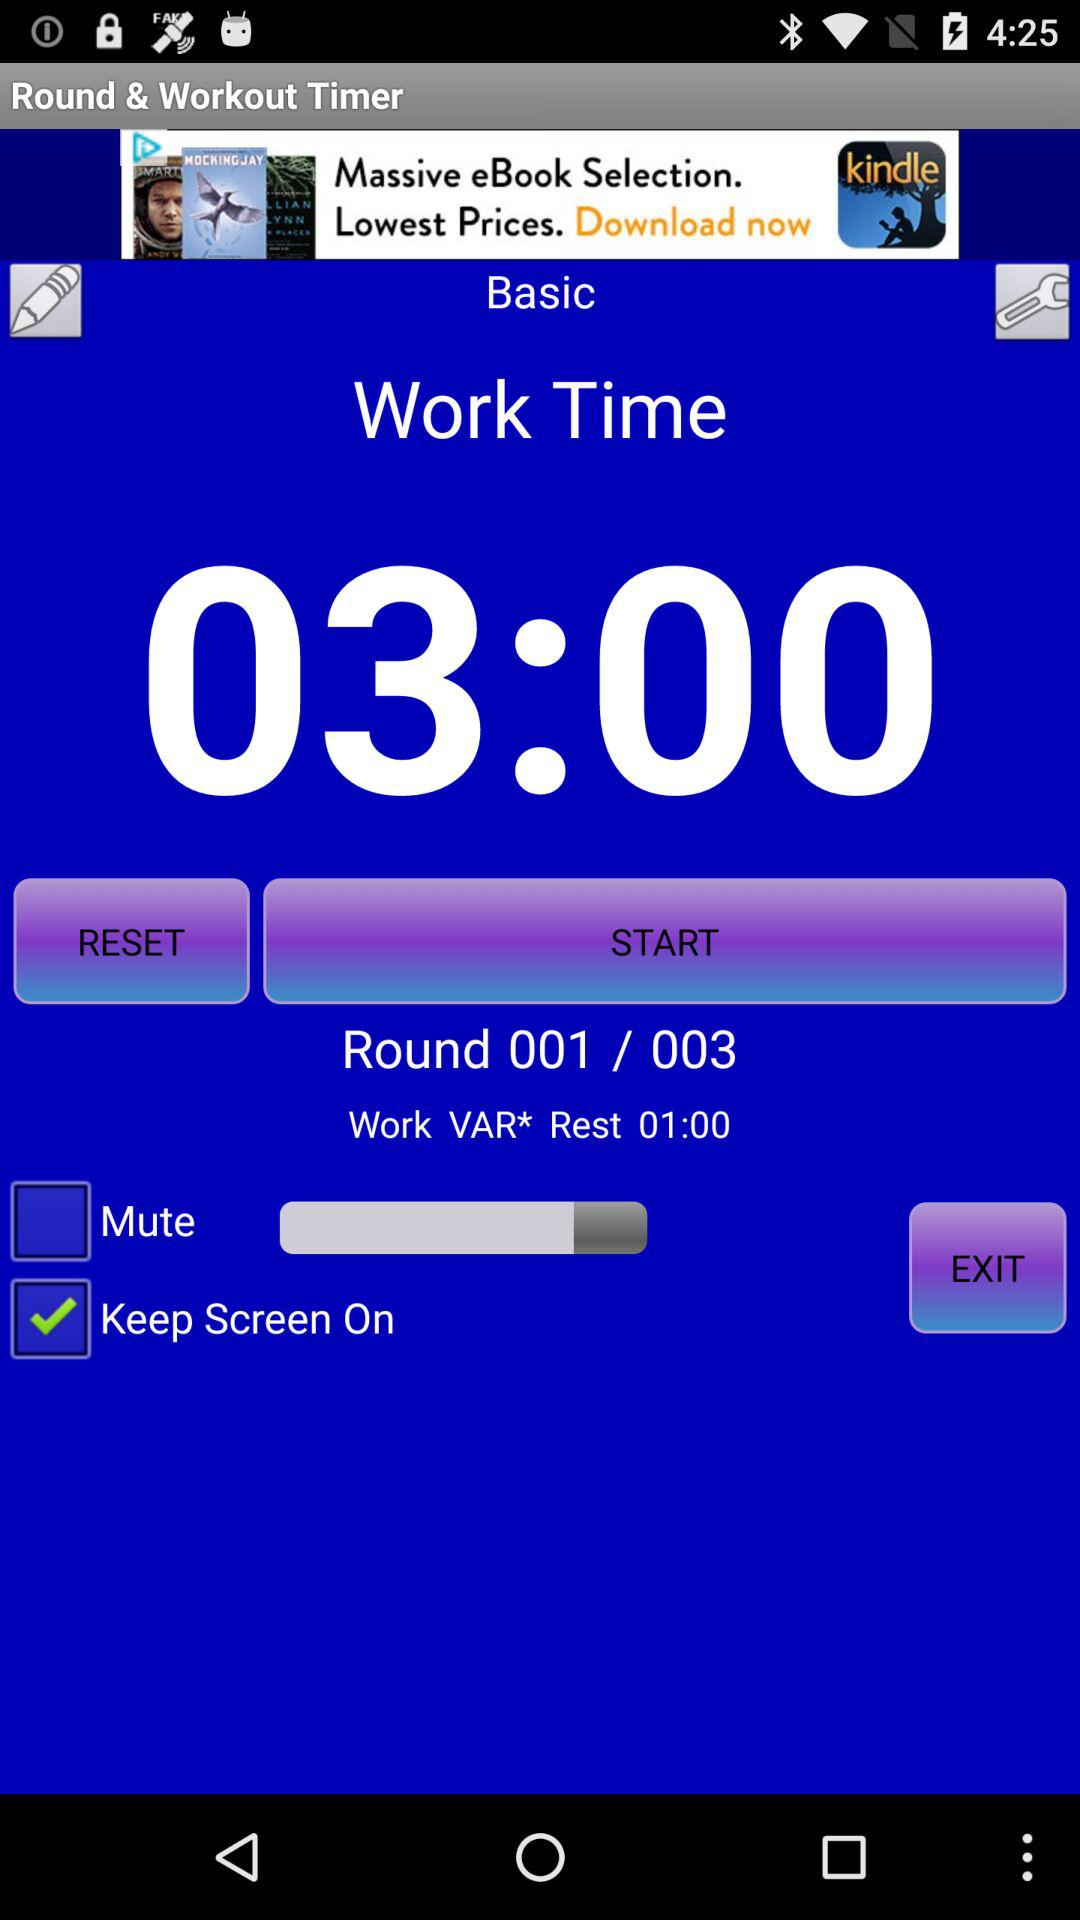What is the status of "Mute"? The status of "Mute" is "off". 